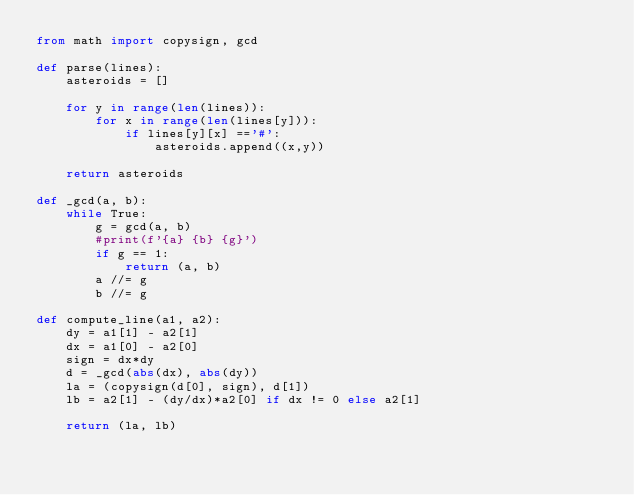Convert code to text. <code><loc_0><loc_0><loc_500><loc_500><_Python_>from math import copysign, gcd

def parse(lines):
    asteroids = []

    for y in range(len(lines)):
        for x in range(len(lines[y])):
            if lines[y][x] =='#':
                asteroids.append((x,y))

    return asteroids

def _gcd(a, b):
    while True:
        g = gcd(a, b)
        #print(f'{a} {b} {g}')
        if g == 1:
            return (a, b)
        a //= g
        b //= g

def compute_line(a1, a2):
    dy = a1[1] - a2[1]
    dx = a1[0] - a2[0]
    sign = dx*dy
    d = _gcd(abs(dx), abs(dy))
    la = (copysign(d[0], sign), d[1])
    lb = a2[1] - (dy/dx)*a2[0] if dx != 0 else a2[1]

    return (la, lb)</code> 